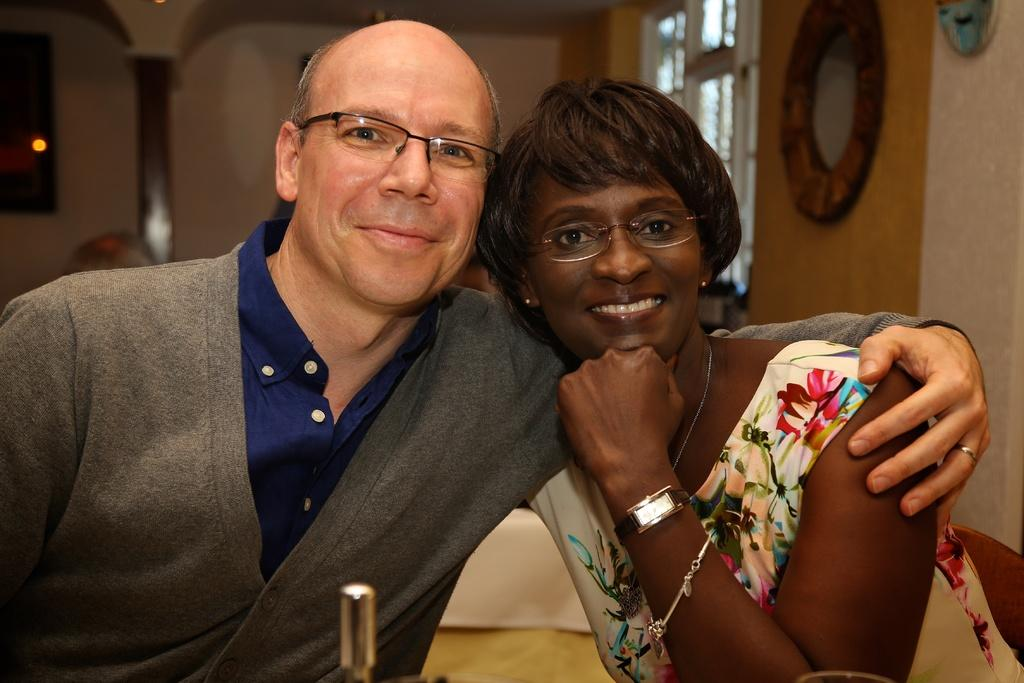How many people are in the image? There are two people in the image, a man and a woman. What are the man and woman doing in the image? The man and woman are sitting in the image. What expressions do the man and woman have in the image? The man and woman are both smiling in the image. What can be seen on the wall in the image? There are frames on the wall in the image. How would you describe the background of the image? The background of the image is blurry. Is there a cobweb visible in the image? There is no cobweb present in the image. How does the man control the woman's emotions in the image? The image does not depict any control over the woman's emotions, as both the man and woman are smiling and appear to be enjoying each other's company. 